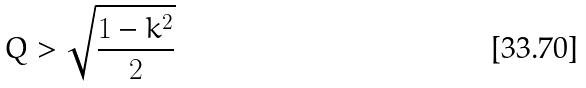Convert formula to latex. <formula><loc_0><loc_0><loc_500><loc_500>Q > \sqrt { \frac { 1 - k ^ { 2 } } { 2 } }</formula> 